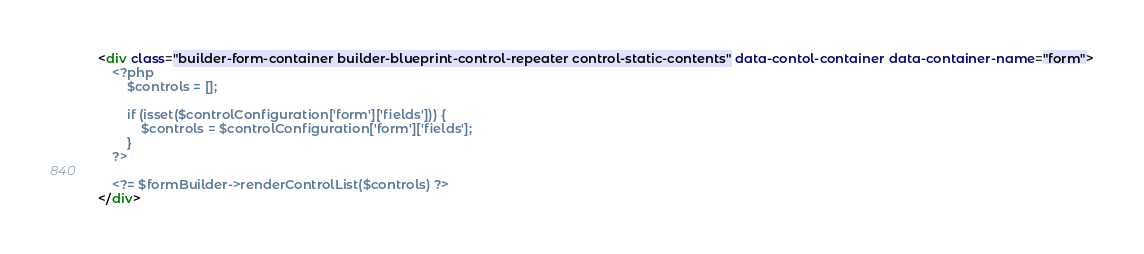Convert code to text. <code><loc_0><loc_0><loc_500><loc_500><_HTML_><div class="builder-form-container builder-blueprint-control-repeater control-static-contents" data-contol-container data-container-name="form">
    <?php
        $controls = [];

        if (isset($controlConfiguration['form']['fields'])) {
            $controls = $controlConfiguration['form']['fields'];
        }
    ?>

    <?= $formBuilder->renderControlList($controls) ?>
</div>
</code> 